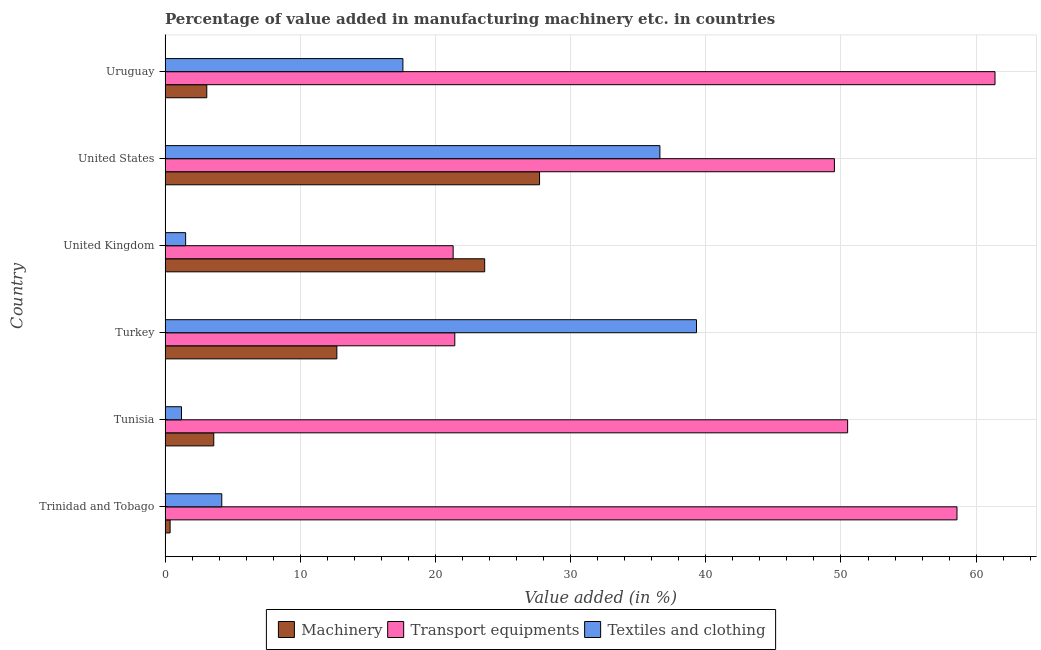Are the number of bars per tick equal to the number of legend labels?
Provide a short and direct response. Yes. Are the number of bars on each tick of the Y-axis equal?
Your response must be concise. Yes. How many bars are there on the 3rd tick from the top?
Ensure brevity in your answer.  3. How many bars are there on the 6th tick from the bottom?
Offer a terse response. 3. What is the label of the 5th group of bars from the top?
Keep it short and to the point. Tunisia. What is the value added in manufacturing machinery in Turkey?
Make the answer very short. 12.71. Across all countries, what is the maximum value added in manufacturing machinery?
Provide a short and direct response. 27.7. Across all countries, what is the minimum value added in manufacturing machinery?
Give a very brief answer. 0.37. In which country was the value added in manufacturing textile and clothing maximum?
Provide a short and direct response. Turkey. What is the total value added in manufacturing machinery in the graph?
Ensure brevity in your answer.  71.11. What is the difference between the value added in manufacturing machinery in United States and that in Uruguay?
Provide a short and direct response. 24.62. What is the difference between the value added in manufacturing machinery in Trinidad and Tobago and the value added in manufacturing textile and clothing in United States?
Offer a very short reply. -36.23. What is the average value added in manufacturing transport equipments per country?
Offer a very short reply. 43.79. What is the difference between the value added in manufacturing machinery and value added in manufacturing textile and clothing in Turkey?
Your response must be concise. -26.61. What is the ratio of the value added in manufacturing machinery in United Kingdom to that in Uruguay?
Make the answer very short. 7.67. Is the value added in manufacturing textile and clothing in Trinidad and Tobago less than that in United Kingdom?
Ensure brevity in your answer.  No. Is the difference between the value added in manufacturing textile and clothing in Turkey and Uruguay greater than the difference between the value added in manufacturing machinery in Turkey and Uruguay?
Make the answer very short. Yes. What is the difference between the highest and the second highest value added in manufacturing textile and clothing?
Offer a terse response. 2.71. What is the difference between the highest and the lowest value added in manufacturing textile and clothing?
Ensure brevity in your answer.  38.1. In how many countries, is the value added in manufacturing textile and clothing greater than the average value added in manufacturing textile and clothing taken over all countries?
Your answer should be compact. 3. What does the 3rd bar from the top in Tunisia represents?
Ensure brevity in your answer.  Machinery. What does the 2nd bar from the bottom in Uruguay represents?
Give a very brief answer. Transport equipments. How many countries are there in the graph?
Give a very brief answer. 6. Does the graph contain any zero values?
Offer a very short reply. No. Does the graph contain grids?
Give a very brief answer. Yes. How many legend labels are there?
Your answer should be very brief. 3. What is the title of the graph?
Your response must be concise. Percentage of value added in manufacturing machinery etc. in countries. What is the label or title of the X-axis?
Make the answer very short. Value added (in %). What is the label or title of the Y-axis?
Your answer should be compact. Country. What is the Value added (in %) of Machinery in Trinidad and Tobago?
Ensure brevity in your answer.  0.37. What is the Value added (in %) of Transport equipments in Trinidad and Tobago?
Make the answer very short. 58.58. What is the Value added (in %) of Textiles and clothing in Trinidad and Tobago?
Provide a short and direct response. 4.19. What is the Value added (in %) in Machinery in Tunisia?
Offer a terse response. 3.6. What is the Value added (in %) of Transport equipments in Tunisia?
Your response must be concise. 50.49. What is the Value added (in %) of Textiles and clothing in Tunisia?
Offer a very short reply. 1.21. What is the Value added (in %) in Machinery in Turkey?
Provide a short and direct response. 12.71. What is the Value added (in %) of Transport equipments in Turkey?
Your answer should be very brief. 21.43. What is the Value added (in %) of Textiles and clothing in Turkey?
Make the answer very short. 39.31. What is the Value added (in %) in Machinery in United Kingdom?
Make the answer very short. 23.64. What is the Value added (in %) in Transport equipments in United Kingdom?
Offer a terse response. 21.31. What is the Value added (in %) of Textiles and clothing in United Kingdom?
Offer a terse response. 1.52. What is the Value added (in %) of Machinery in United States?
Your answer should be compact. 27.7. What is the Value added (in %) in Transport equipments in United States?
Make the answer very short. 49.51. What is the Value added (in %) of Textiles and clothing in United States?
Your answer should be compact. 36.61. What is the Value added (in %) of Machinery in Uruguay?
Give a very brief answer. 3.08. What is the Value added (in %) in Transport equipments in Uruguay?
Your answer should be compact. 61.4. What is the Value added (in %) in Textiles and clothing in Uruguay?
Provide a succinct answer. 17.59. Across all countries, what is the maximum Value added (in %) of Machinery?
Make the answer very short. 27.7. Across all countries, what is the maximum Value added (in %) in Transport equipments?
Ensure brevity in your answer.  61.4. Across all countries, what is the maximum Value added (in %) of Textiles and clothing?
Your answer should be compact. 39.31. Across all countries, what is the minimum Value added (in %) in Machinery?
Give a very brief answer. 0.37. Across all countries, what is the minimum Value added (in %) of Transport equipments?
Provide a succinct answer. 21.31. Across all countries, what is the minimum Value added (in %) in Textiles and clothing?
Offer a very short reply. 1.21. What is the total Value added (in %) in Machinery in the graph?
Offer a very short reply. 71.11. What is the total Value added (in %) of Transport equipments in the graph?
Provide a short and direct response. 262.73. What is the total Value added (in %) of Textiles and clothing in the graph?
Provide a succinct answer. 100.44. What is the difference between the Value added (in %) in Machinery in Trinidad and Tobago and that in Tunisia?
Ensure brevity in your answer.  -3.23. What is the difference between the Value added (in %) of Transport equipments in Trinidad and Tobago and that in Tunisia?
Offer a terse response. 8.09. What is the difference between the Value added (in %) in Textiles and clothing in Trinidad and Tobago and that in Tunisia?
Offer a very short reply. 2.98. What is the difference between the Value added (in %) in Machinery in Trinidad and Tobago and that in Turkey?
Offer a very short reply. -12.34. What is the difference between the Value added (in %) of Transport equipments in Trinidad and Tobago and that in Turkey?
Give a very brief answer. 37.15. What is the difference between the Value added (in %) of Textiles and clothing in Trinidad and Tobago and that in Turkey?
Provide a succinct answer. -35.12. What is the difference between the Value added (in %) of Machinery in Trinidad and Tobago and that in United Kingdom?
Offer a very short reply. -23.27. What is the difference between the Value added (in %) of Transport equipments in Trinidad and Tobago and that in United Kingdom?
Your answer should be compact. 37.27. What is the difference between the Value added (in %) of Textiles and clothing in Trinidad and Tobago and that in United Kingdom?
Make the answer very short. 2.67. What is the difference between the Value added (in %) in Machinery in Trinidad and Tobago and that in United States?
Provide a short and direct response. -27.33. What is the difference between the Value added (in %) of Transport equipments in Trinidad and Tobago and that in United States?
Your answer should be compact. 9.07. What is the difference between the Value added (in %) in Textiles and clothing in Trinidad and Tobago and that in United States?
Offer a terse response. -32.41. What is the difference between the Value added (in %) in Machinery in Trinidad and Tobago and that in Uruguay?
Provide a succinct answer. -2.71. What is the difference between the Value added (in %) of Transport equipments in Trinidad and Tobago and that in Uruguay?
Ensure brevity in your answer.  -2.81. What is the difference between the Value added (in %) in Textiles and clothing in Trinidad and Tobago and that in Uruguay?
Your response must be concise. -13.4. What is the difference between the Value added (in %) of Machinery in Tunisia and that in Turkey?
Give a very brief answer. -9.11. What is the difference between the Value added (in %) in Transport equipments in Tunisia and that in Turkey?
Provide a short and direct response. 29.06. What is the difference between the Value added (in %) of Textiles and clothing in Tunisia and that in Turkey?
Provide a short and direct response. -38.1. What is the difference between the Value added (in %) in Machinery in Tunisia and that in United Kingdom?
Offer a terse response. -20.04. What is the difference between the Value added (in %) in Transport equipments in Tunisia and that in United Kingdom?
Provide a short and direct response. 29.18. What is the difference between the Value added (in %) in Textiles and clothing in Tunisia and that in United Kingdom?
Provide a succinct answer. -0.31. What is the difference between the Value added (in %) of Machinery in Tunisia and that in United States?
Make the answer very short. -24.1. What is the difference between the Value added (in %) of Textiles and clothing in Tunisia and that in United States?
Give a very brief answer. -35.39. What is the difference between the Value added (in %) in Machinery in Tunisia and that in Uruguay?
Make the answer very short. 0.52. What is the difference between the Value added (in %) of Transport equipments in Tunisia and that in Uruguay?
Your answer should be compact. -10.9. What is the difference between the Value added (in %) in Textiles and clothing in Tunisia and that in Uruguay?
Provide a short and direct response. -16.38. What is the difference between the Value added (in %) of Machinery in Turkey and that in United Kingdom?
Ensure brevity in your answer.  -10.94. What is the difference between the Value added (in %) in Transport equipments in Turkey and that in United Kingdom?
Make the answer very short. 0.12. What is the difference between the Value added (in %) of Textiles and clothing in Turkey and that in United Kingdom?
Offer a terse response. 37.79. What is the difference between the Value added (in %) of Machinery in Turkey and that in United States?
Ensure brevity in your answer.  -15. What is the difference between the Value added (in %) in Transport equipments in Turkey and that in United States?
Ensure brevity in your answer.  -28.08. What is the difference between the Value added (in %) in Textiles and clothing in Turkey and that in United States?
Ensure brevity in your answer.  2.71. What is the difference between the Value added (in %) in Machinery in Turkey and that in Uruguay?
Offer a terse response. 9.62. What is the difference between the Value added (in %) of Transport equipments in Turkey and that in Uruguay?
Provide a short and direct response. -39.96. What is the difference between the Value added (in %) of Textiles and clothing in Turkey and that in Uruguay?
Give a very brief answer. 21.72. What is the difference between the Value added (in %) in Machinery in United Kingdom and that in United States?
Offer a terse response. -4.06. What is the difference between the Value added (in %) of Transport equipments in United Kingdom and that in United States?
Offer a terse response. -28.21. What is the difference between the Value added (in %) in Textiles and clothing in United Kingdom and that in United States?
Keep it short and to the point. -35.09. What is the difference between the Value added (in %) of Machinery in United Kingdom and that in Uruguay?
Offer a very short reply. 20.56. What is the difference between the Value added (in %) of Transport equipments in United Kingdom and that in Uruguay?
Your answer should be very brief. -40.09. What is the difference between the Value added (in %) of Textiles and clothing in United Kingdom and that in Uruguay?
Keep it short and to the point. -16.07. What is the difference between the Value added (in %) in Machinery in United States and that in Uruguay?
Make the answer very short. 24.62. What is the difference between the Value added (in %) in Transport equipments in United States and that in Uruguay?
Ensure brevity in your answer.  -11.88. What is the difference between the Value added (in %) in Textiles and clothing in United States and that in Uruguay?
Ensure brevity in your answer.  19.01. What is the difference between the Value added (in %) of Machinery in Trinidad and Tobago and the Value added (in %) of Transport equipments in Tunisia?
Keep it short and to the point. -50.12. What is the difference between the Value added (in %) in Machinery in Trinidad and Tobago and the Value added (in %) in Textiles and clothing in Tunisia?
Your answer should be compact. -0.84. What is the difference between the Value added (in %) in Transport equipments in Trinidad and Tobago and the Value added (in %) in Textiles and clothing in Tunisia?
Offer a very short reply. 57.37. What is the difference between the Value added (in %) of Machinery in Trinidad and Tobago and the Value added (in %) of Transport equipments in Turkey?
Provide a succinct answer. -21.06. What is the difference between the Value added (in %) of Machinery in Trinidad and Tobago and the Value added (in %) of Textiles and clothing in Turkey?
Ensure brevity in your answer.  -38.94. What is the difference between the Value added (in %) in Transport equipments in Trinidad and Tobago and the Value added (in %) in Textiles and clothing in Turkey?
Ensure brevity in your answer.  19.27. What is the difference between the Value added (in %) in Machinery in Trinidad and Tobago and the Value added (in %) in Transport equipments in United Kingdom?
Give a very brief answer. -20.94. What is the difference between the Value added (in %) in Machinery in Trinidad and Tobago and the Value added (in %) in Textiles and clothing in United Kingdom?
Offer a terse response. -1.15. What is the difference between the Value added (in %) of Transport equipments in Trinidad and Tobago and the Value added (in %) of Textiles and clothing in United Kingdom?
Offer a very short reply. 57.06. What is the difference between the Value added (in %) of Machinery in Trinidad and Tobago and the Value added (in %) of Transport equipments in United States?
Your answer should be compact. -49.14. What is the difference between the Value added (in %) of Machinery in Trinidad and Tobago and the Value added (in %) of Textiles and clothing in United States?
Offer a very short reply. -36.23. What is the difference between the Value added (in %) of Transport equipments in Trinidad and Tobago and the Value added (in %) of Textiles and clothing in United States?
Make the answer very short. 21.98. What is the difference between the Value added (in %) of Machinery in Trinidad and Tobago and the Value added (in %) of Transport equipments in Uruguay?
Make the answer very short. -61.02. What is the difference between the Value added (in %) of Machinery in Trinidad and Tobago and the Value added (in %) of Textiles and clothing in Uruguay?
Make the answer very short. -17.22. What is the difference between the Value added (in %) in Transport equipments in Trinidad and Tobago and the Value added (in %) in Textiles and clothing in Uruguay?
Your response must be concise. 40.99. What is the difference between the Value added (in %) in Machinery in Tunisia and the Value added (in %) in Transport equipments in Turkey?
Provide a short and direct response. -17.83. What is the difference between the Value added (in %) in Machinery in Tunisia and the Value added (in %) in Textiles and clothing in Turkey?
Your answer should be compact. -35.71. What is the difference between the Value added (in %) in Transport equipments in Tunisia and the Value added (in %) in Textiles and clothing in Turkey?
Provide a succinct answer. 11.18. What is the difference between the Value added (in %) in Machinery in Tunisia and the Value added (in %) in Transport equipments in United Kingdom?
Offer a terse response. -17.71. What is the difference between the Value added (in %) in Machinery in Tunisia and the Value added (in %) in Textiles and clothing in United Kingdom?
Make the answer very short. 2.08. What is the difference between the Value added (in %) in Transport equipments in Tunisia and the Value added (in %) in Textiles and clothing in United Kingdom?
Give a very brief answer. 48.97. What is the difference between the Value added (in %) in Machinery in Tunisia and the Value added (in %) in Transport equipments in United States?
Give a very brief answer. -45.91. What is the difference between the Value added (in %) of Machinery in Tunisia and the Value added (in %) of Textiles and clothing in United States?
Your answer should be very brief. -33. What is the difference between the Value added (in %) of Transport equipments in Tunisia and the Value added (in %) of Textiles and clothing in United States?
Offer a very short reply. 13.89. What is the difference between the Value added (in %) of Machinery in Tunisia and the Value added (in %) of Transport equipments in Uruguay?
Ensure brevity in your answer.  -57.8. What is the difference between the Value added (in %) of Machinery in Tunisia and the Value added (in %) of Textiles and clothing in Uruguay?
Your response must be concise. -13.99. What is the difference between the Value added (in %) in Transport equipments in Tunisia and the Value added (in %) in Textiles and clothing in Uruguay?
Give a very brief answer. 32.9. What is the difference between the Value added (in %) of Machinery in Turkey and the Value added (in %) of Transport equipments in United Kingdom?
Keep it short and to the point. -8.6. What is the difference between the Value added (in %) of Machinery in Turkey and the Value added (in %) of Textiles and clothing in United Kingdom?
Offer a terse response. 11.19. What is the difference between the Value added (in %) of Transport equipments in Turkey and the Value added (in %) of Textiles and clothing in United Kingdom?
Offer a terse response. 19.91. What is the difference between the Value added (in %) of Machinery in Turkey and the Value added (in %) of Transport equipments in United States?
Your response must be concise. -36.81. What is the difference between the Value added (in %) of Machinery in Turkey and the Value added (in %) of Textiles and clothing in United States?
Keep it short and to the point. -23.9. What is the difference between the Value added (in %) of Transport equipments in Turkey and the Value added (in %) of Textiles and clothing in United States?
Your answer should be very brief. -15.17. What is the difference between the Value added (in %) of Machinery in Turkey and the Value added (in %) of Transport equipments in Uruguay?
Keep it short and to the point. -48.69. What is the difference between the Value added (in %) in Machinery in Turkey and the Value added (in %) in Textiles and clothing in Uruguay?
Ensure brevity in your answer.  -4.89. What is the difference between the Value added (in %) of Transport equipments in Turkey and the Value added (in %) of Textiles and clothing in Uruguay?
Make the answer very short. 3.84. What is the difference between the Value added (in %) in Machinery in United Kingdom and the Value added (in %) in Transport equipments in United States?
Ensure brevity in your answer.  -25.87. What is the difference between the Value added (in %) in Machinery in United Kingdom and the Value added (in %) in Textiles and clothing in United States?
Provide a short and direct response. -12.96. What is the difference between the Value added (in %) in Transport equipments in United Kingdom and the Value added (in %) in Textiles and clothing in United States?
Make the answer very short. -15.3. What is the difference between the Value added (in %) of Machinery in United Kingdom and the Value added (in %) of Transport equipments in Uruguay?
Provide a short and direct response. -37.75. What is the difference between the Value added (in %) in Machinery in United Kingdom and the Value added (in %) in Textiles and clothing in Uruguay?
Offer a very short reply. 6.05. What is the difference between the Value added (in %) in Transport equipments in United Kingdom and the Value added (in %) in Textiles and clothing in Uruguay?
Provide a succinct answer. 3.72. What is the difference between the Value added (in %) in Machinery in United States and the Value added (in %) in Transport equipments in Uruguay?
Give a very brief answer. -33.69. What is the difference between the Value added (in %) in Machinery in United States and the Value added (in %) in Textiles and clothing in Uruguay?
Your response must be concise. 10.11. What is the difference between the Value added (in %) in Transport equipments in United States and the Value added (in %) in Textiles and clothing in Uruguay?
Give a very brief answer. 31.92. What is the average Value added (in %) of Machinery per country?
Your answer should be compact. 11.85. What is the average Value added (in %) of Transport equipments per country?
Give a very brief answer. 43.79. What is the average Value added (in %) of Textiles and clothing per country?
Provide a short and direct response. 16.74. What is the difference between the Value added (in %) in Machinery and Value added (in %) in Transport equipments in Trinidad and Tobago?
Make the answer very short. -58.21. What is the difference between the Value added (in %) in Machinery and Value added (in %) in Textiles and clothing in Trinidad and Tobago?
Give a very brief answer. -3.82. What is the difference between the Value added (in %) in Transport equipments and Value added (in %) in Textiles and clothing in Trinidad and Tobago?
Your response must be concise. 54.39. What is the difference between the Value added (in %) of Machinery and Value added (in %) of Transport equipments in Tunisia?
Provide a short and direct response. -46.89. What is the difference between the Value added (in %) of Machinery and Value added (in %) of Textiles and clothing in Tunisia?
Provide a short and direct response. 2.39. What is the difference between the Value added (in %) of Transport equipments and Value added (in %) of Textiles and clothing in Tunisia?
Your answer should be very brief. 49.28. What is the difference between the Value added (in %) in Machinery and Value added (in %) in Transport equipments in Turkey?
Make the answer very short. -8.72. What is the difference between the Value added (in %) in Machinery and Value added (in %) in Textiles and clothing in Turkey?
Ensure brevity in your answer.  -26.61. What is the difference between the Value added (in %) in Transport equipments and Value added (in %) in Textiles and clothing in Turkey?
Offer a terse response. -17.88. What is the difference between the Value added (in %) in Machinery and Value added (in %) in Transport equipments in United Kingdom?
Ensure brevity in your answer.  2.33. What is the difference between the Value added (in %) of Machinery and Value added (in %) of Textiles and clothing in United Kingdom?
Give a very brief answer. 22.12. What is the difference between the Value added (in %) in Transport equipments and Value added (in %) in Textiles and clothing in United Kingdom?
Make the answer very short. 19.79. What is the difference between the Value added (in %) of Machinery and Value added (in %) of Transport equipments in United States?
Offer a very short reply. -21.81. What is the difference between the Value added (in %) in Machinery and Value added (in %) in Textiles and clothing in United States?
Provide a succinct answer. -8.9. What is the difference between the Value added (in %) in Transport equipments and Value added (in %) in Textiles and clothing in United States?
Your answer should be compact. 12.91. What is the difference between the Value added (in %) in Machinery and Value added (in %) in Transport equipments in Uruguay?
Keep it short and to the point. -58.31. What is the difference between the Value added (in %) of Machinery and Value added (in %) of Textiles and clothing in Uruguay?
Ensure brevity in your answer.  -14.51. What is the difference between the Value added (in %) in Transport equipments and Value added (in %) in Textiles and clothing in Uruguay?
Provide a succinct answer. 43.8. What is the ratio of the Value added (in %) of Machinery in Trinidad and Tobago to that in Tunisia?
Your answer should be very brief. 0.1. What is the ratio of the Value added (in %) of Transport equipments in Trinidad and Tobago to that in Tunisia?
Your answer should be very brief. 1.16. What is the ratio of the Value added (in %) in Textiles and clothing in Trinidad and Tobago to that in Tunisia?
Your answer should be compact. 3.46. What is the ratio of the Value added (in %) in Machinery in Trinidad and Tobago to that in Turkey?
Offer a terse response. 0.03. What is the ratio of the Value added (in %) in Transport equipments in Trinidad and Tobago to that in Turkey?
Make the answer very short. 2.73. What is the ratio of the Value added (in %) of Textiles and clothing in Trinidad and Tobago to that in Turkey?
Offer a very short reply. 0.11. What is the ratio of the Value added (in %) in Machinery in Trinidad and Tobago to that in United Kingdom?
Your answer should be compact. 0.02. What is the ratio of the Value added (in %) of Transport equipments in Trinidad and Tobago to that in United Kingdom?
Make the answer very short. 2.75. What is the ratio of the Value added (in %) of Textiles and clothing in Trinidad and Tobago to that in United Kingdom?
Your answer should be compact. 2.76. What is the ratio of the Value added (in %) in Machinery in Trinidad and Tobago to that in United States?
Provide a short and direct response. 0.01. What is the ratio of the Value added (in %) in Transport equipments in Trinidad and Tobago to that in United States?
Provide a short and direct response. 1.18. What is the ratio of the Value added (in %) in Textiles and clothing in Trinidad and Tobago to that in United States?
Your answer should be compact. 0.11. What is the ratio of the Value added (in %) in Machinery in Trinidad and Tobago to that in Uruguay?
Offer a terse response. 0.12. What is the ratio of the Value added (in %) in Transport equipments in Trinidad and Tobago to that in Uruguay?
Offer a terse response. 0.95. What is the ratio of the Value added (in %) in Textiles and clothing in Trinidad and Tobago to that in Uruguay?
Provide a succinct answer. 0.24. What is the ratio of the Value added (in %) of Machinery in Tunisia to that in Turkey?
Your answer should be compact. 0.28. What is the ratio of the Value added (in %) of Transport equipments in Tunisia to that in Turkey?
Your answer should be very brief. 2.36. What is the ratio of the Value added (in %) of Textiles and clothing in Tunisia to that in Turkey?
Give a very brief answer. 0.03. What is the ratio of the Value added (in %) of Machinery in Tunisia to that in United Kingdom?
Provide a succinct answer. 0.15. What is the ratio of the Value added (in %) in Transport equipments in Tunisia to that in United Kingdom?
Your answer should be compact. 2.37. What is the ratio of the Value added (in %) of Textiles and clothing in Tunisia to that in United Kingdom?
Offer a terse response. 0.8. What is the ratio of the Value added (in %) in Machinery in Tunisia to that in United States?
Your response must be concise. 0.13. What is the ratio of the Value added (in %) of Transport equipments in Tunisia to that in United States?
Your response must be concise. 1.02. What is the ratio of the Value added (in %) in Textiles and clothing in Tunisia to that in United States?
Your response must be concise. 0.03. What is the ratio of the Value added (in %) in Machinery in Tunisia to that in Uruguay?
Your answer should be compact. 1.17. What is the ratio of the Value added (in %) in Transport equipments in Tunisia to that in Uruguay?
Your response must be concise. 0.82. What is the ratio of the Value added (in %) in Textiles and clothing in Tunisia to that in Uruguay?
Provide a short and direct response. 0.07. What is the ratio of the Value added (in %) of Machinery in Turkey to that in United Kingdom?
Provide a succinct answer. 0.54. What is the ratio of the Value added (in %) of Textiles and clothing in Turkey to that in United Kingdom?
Make the answer very short. 25.86. What is the ratio of the Value added (in %) of Machinery in Turkey to that in United States?
Ensure brevity in your answer.  0.46. What is the ratio of the Value added (in %) in Transport equipments in Turkey to that in United States?
Offer a very short reply. 0.43. What is the ratio of the Value added (in %) in Textiles and clothing in Turkey to that in United States?
Your answer should be compact. 1.07. What is the ratio of the Value added (in %) in Machinery in Turkey to that in Uruguay?
Provide a succinct answer. 4.12. What is the ratio of the Value added (in %) in Transport equipments in Turkey to that in Uruguay?
Provide a short and direct response. 0.35. What is the ratio of the Value added (in %) in Textiles and clothing in Turkey to that in Uruguay?
Keep it short and to the point. 2.23. What is the ratio of the Value added (in %) of Machinery in United Kingdom to that in United States?
Provide a succinct answer. 0.85. What is the ratio of the Value added (in %) in Transport equipments in United Kingdom to that in United States?
Provide a succinct answer. 0.43. What is the ratio of the Value added (in %) of Textiles and clothing in United Kingdom to that in United States?
Your response must be concise. 0.04. What is the ratio of the Value added (in %) of Machinery in United Kingdom to that in Uruguay?
Offer a terse response. 7.67. What is the ratio of the Value added (in %) of Transport equipments in United Kingdom to that in Uruguay?
Offer a terse response. 0.35. What is the ratio of the Value added (in %) of Textiles and clothing in United Kingdom to that in Uruguay?
Offer a very short reply. 0.09. What is the ratio of the Value added (in %) of Machinery in United States to that in Uruguay?
Provide a short and direct response. 8.98. What is the ratio of the Value added (in %) of Transport equipments in United States to that in Uruguay?
Provide a short and direct response. 0.81. What is the ratio of the Value added (in %) of Textiles and clothing in United States to that in Uruguay?
Give a very brief answer. 2.08. What is the difference between the highest and the second highest Value added (in %) in Machinery?
Keep it short and to the point. 4.06. What is the difference between the highest and the second highest Value added (in %) of Transport equipments?
Provide a succinct answer. 2.81. What is the difference between the highest and the second highest Value added (in %) in Textiles and clothing?
Your response must be concise. 2.71. What is the difference between the highest and the lowest Value added (in %) in Machinery?
Make the answer very short. 27.33. What is the difference between the highest and the lowest Value added (in %) in Transport equipments?
Your answer should be very brief. 40.09. What is the difference between the highest and the lowest Value added (in %) of Textiles and clothing?
Keep it short and to the point. 38.1. 